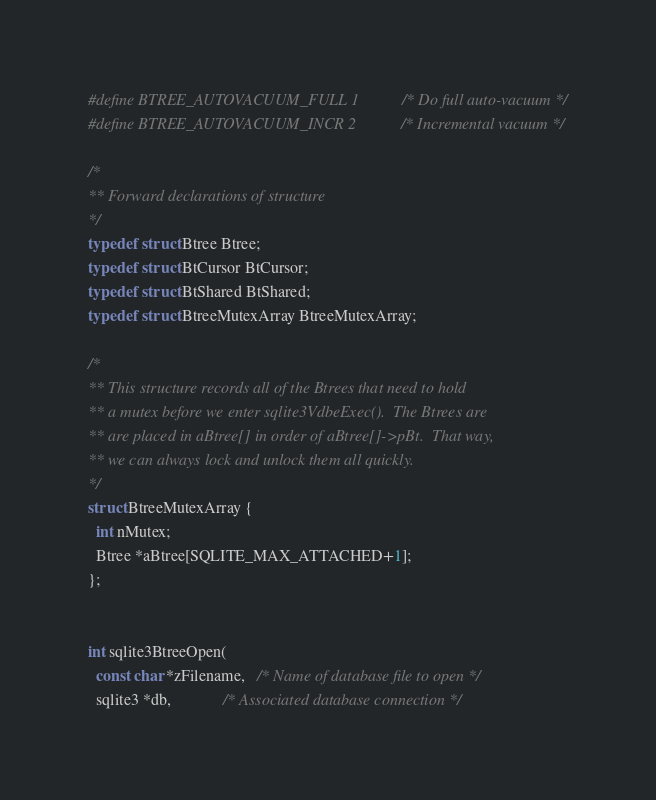<code> <loc_0><loc_0><loc_500><loc_500><_C_>#define BTREE_AUTOVACUUM_FULL 1        /* Do full auto-vacuum */
#define BTREE_AUTOVACUUM_INCR 2        /* Incremental vacuum */

/*
** Forward declarations of structure
*/
typedef struct Btree Btree;
typedef struct BtCursor BtCursor;
typedef struct BtShared BtShared;
typedef struct BtreeMutexArray BtreeMutexArray;

/*
** This structure records all of the Btrees that need to hold
** a mutex before we enter sqlite3VdbeExec().  The Btrees are
** are placed in aBtree[] in order of aBtree[]->pBt.  That way,
** we can always lock and unlock them all quickly.
*/
struct BtreeMutexArray {
  int nMutex;
  Btree *aBtree[SQLITE_MAX_ATTACHED+1];
};


int sqlite3BtreeOpen(
  const char *zFilename,   /* Name of database file to open */
  sqlite3 *db,             /* Associated database connection */</code> 